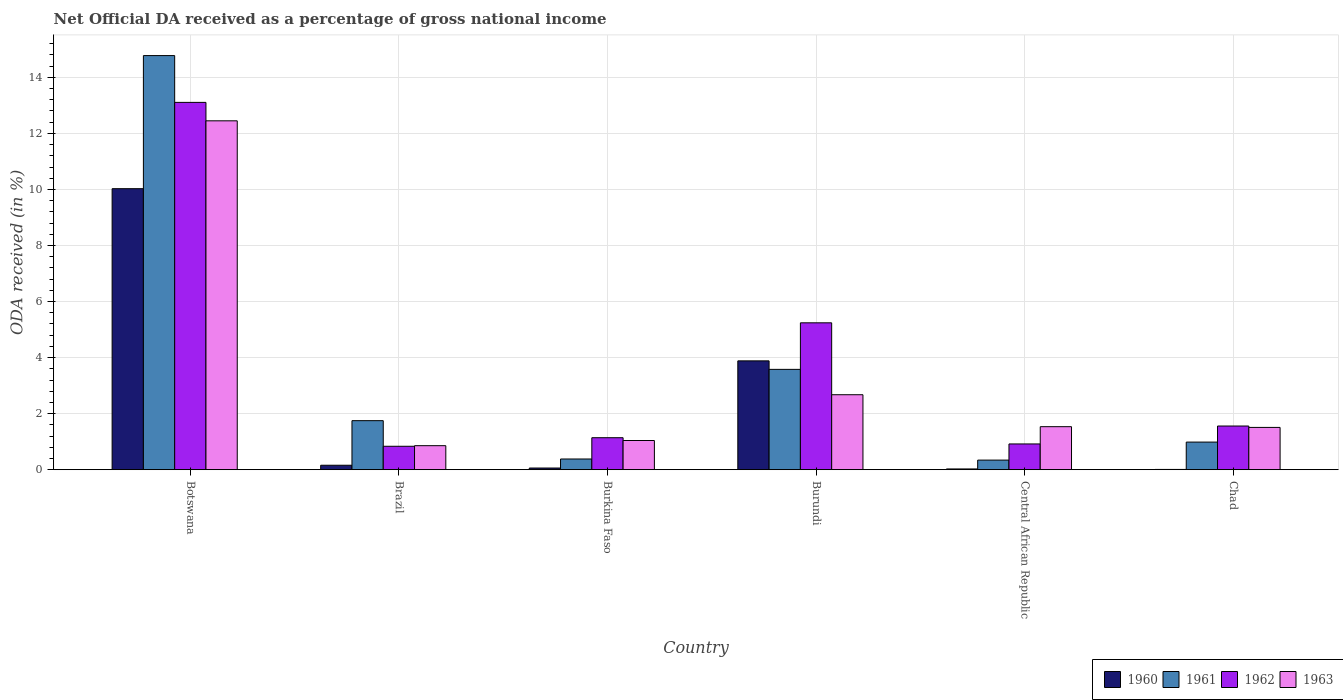How many different coloured bars are there?
Offer a terse response. 4. Are the number of bars on each tick of the X-axis equal?
Provide a succinct answer. Yes. How many bars are there on the 1st tick from the left?
Provide a short and direct response. 4. How many bars are there on the 1st tick from the right?
Your response must be concise. 4. What is the label of the 2nd group of bars from the left?
Give a very brief answer. Brazil. In how many cases, is the number of bars for a given country not equal to the number of legend labels?
Your answer should be very brief. 0. What is the net official DA received in 1962 in Burundi?
Offer a terse response. 5.24. Across all countries, what is the maximum net official DA received in 1962?
Make the answer very short. 13.11. Across all countries, what is the minimum net official DA received in 1960?
Your answer should be very brief. 0.01. In which country was the net official DA received in 1961 maximum?
Make the answer very short. Botswana. In which country was the net official DA received in 1961 minimum?
Ensure brevity in your answer.  Central African Republic. What is the total net official DA received in 1960 in the graph?
Your answer should be compact. 14.17. What is the difference between the net official DA received in 1961 in Botswana and that in Burkina Faso?
Your answer should be very brief. 14.4. What is the difference between the net official DA received in 1963 in Brazil and the net official DA received in 1960 in Burundi?
Your response must be concise. -3.03. What is the average net official DA received in 1961 per country?
Keep it short and to the point. 3.64. What is the difference between the net official DA received of/in 1963 and net official DA received of/in 1962 in Central African Republic?
Ensure brevity in your answer.  0.62. In how many countries, is the net official DA received in 1962 greater than 1.2000000000000002 %?
Provide a short and direct response. 3. What is the ratio of the net official DA received in 1960 in Burkina Faso to that in Chad?
Ensure brevity in your answer.  6.2. Is the net official DA received in 1963 in Burundi less than that in Chad?
Your answer should be very brief. No. Is the difference between the net official DA received in 1963 in Burkina Faso and Chad greater than the difference between the net official DA received in 1962 in Burkina Faso and Chad?
Provide a succinct answer. No. What is the difference between the highest and the second highest net official DA received in 1963?
Ensure brevity in your answer.  -1.14. What is the difference between the highest and the lowest net official DA received in 1962?
Your answer should be very brief. 12.27. Is the sum of the net official DA received in 1963 in Brazil and Chad greater than the maximum net official DA received in 1962 across all countries?
Your answer should be very brief. No. Is it the case that in every country, the sum of the net official DA received in 1961 and net official DA received in 1960 is greater than the sum of net official DA received in 1962 and net official DA received in 1963?
Your answer should be very brief. No. Is it the case that in every country, the sum of the net official DA received in 1962 and net official DA received in 1960 is greater than the net official DA received in 1961?
Your answer should be compact. No. Are all the bars in the graph horizontal?
Provide a succinct answer. No. Does the graph contain any zero values?
Offer a very short reply. No. How many legend labels are there?
Ensure brevity in your answer.  4. What is the title of the graph?
Offer a terse response. Net Official DA received as a percentage of gross national income. What is the label or title of the X-axis?
Your answer should be very brief. Country. What is the label or title of the Y-axis?
Your answer should be very brief. ODA received (in %). What is the ODA received (in %) of 1960 in Botswana?
Your answer should be compact. 10.03. What is the ODA received (in %) in 1961 in Botswana?
Offer a terse response. 14.78. What is the ODA received (in %) of 1962 in Botswana?
Offer a terse response. 13.11. What is the ODA received (in %) in 1963 in Botswana?
Provide a short and direct response. 12.45. What is the ODA received (in %) in 1960 in Brazil?
Keep it short and to the point. 0.16. What is the ODA received (in %) of 1961 in Brazil?
Your response must be concise. 1.75. What is the ODA received (in %) in 1962 in Brazil?
Offer a terse response. 0.84. What is the ODA received (in %) in 1963 in Brazil?
Make the answer very short. 0.86. What is the ODA received (in %) of 1960 in Burkina Faso?
Offer a terse response. 0.06. What is the ODA received (in %) of 1961 in Burkina Faso?
Your answer should be very brief. 0.38. What is the ODA received (in %) in 1962 in Burkina Faso?
Offer a terse response. 1.14. What is the ODA received (in %) in 1963 in Burkina Faso?
Offer a very short reply. 1.04. What is the ODA received (in %) of 1960 in Burundi?
Offer a terse response. 3.88. What is the ODA received (in %) of 1961 in Burundi?
Offer a terse response. 3.58. What is the ODA received (in %) in 1962 in Burundi?
Ensure brevity in your answer.  5.24. What is the ODA received (in %) of 1963 in Burundi?
Give a very brief answer. 2.68. What is the ODA received (in %) in 1960 in Central African Republic?
Give a very brief answer. 0.03. What is the ODA received (in %) in 1961 in Central African Republic?
Offer a very short reply. 0.34. What is the ODA received (in %) in 1962 in Central African Republic?
Your answer should be very brief. 0.92. What is the ODA received (in %) in 1963 in Central African Republic?
Offer a terse response. 1.54. What is the ODA received (in %) of 1960 in Chad?
Offer a very short reply. 0.01. What is the ODA received (in %) of 1961 in Chad?
Offer a very short reply. 0.99. What is the ODA received (in %) in 1962 in Chad?
Give a very brief answer. 1.56. What is the ODA received (in %) of 1963 in Chad?
Make the answer very short. 1.51. Across all countries, what is the maximum ODA received (in %) in 1960?
Your answer should be very brief. 10.03. Across all countries, what is the maximum ODA received (in %) of 1961?
Make the answer very short. 14.78. Across all countries, what is the maximum ODA received (in %) of 1962?
Offer a very short reply. 13.11. Across all countries, what is the maximum ODA received (in %) in 1963?
Provide a short and direct response. 12.45. Across all countries, what is the minimum ODA received (in %) in 1960?
Your answer should be very brief. 0.01. Across all countries, what is the minimum ODA received (in %) in 1961?
Your response must be concise. 0.34. Across all countries, what is the minimum ODA received (in %) in 1962?
Ensure brevity in your answer.  0.84. Across all countries, what is the minimum ODA received (in %) of 1963?
Your answer should be compact. 0.86. What is the total ODA received (in %) in 1960 in the graph?
Your answer should be compact. 14.17. What is the total ODA received (in %) of 1961 in the graph?
Provide a short and direct response. 21.82. What is the total ODA received (in %) in 1962 in the graph?
Provide a short and direct response. 22.8. What is the total ODA received (in %) of 1963 in the graph?
Provide a short and direct response. 20.07. What is the difference between the ODA received (in %) in 1960 in Botswana and that in Brazil?
Offer a terse response. 9.87. What is the difference between the ODA received (in %) in 1961 in Botswana and that in Brazil?
Your response must be concise. 13.03. What is the difference between the ODA received (in %) in 1962 in Botswana and that in Brazil?
Offer a terse response. 12.27. What is the difference between the ODA received (in %) of 1963 in Botswana and that in Brazil?
Offer a very short reply. 11.59. What is the difference between the ODA received (in %) of 1960 in Botswana and that in Burkina Faso?
Give a very brief answer. 9.97. What is the difference between the ODA received (in %) of 1961 in Botswana and that in Burkina Faso?
Your response must be concise. 14.39. What is the difference between the ODA received (in %) in 1962 in Botswana and that in Burkina Faso?
Your answer should be very brief. 11.97. What is the difference between the ODA received (in %) in 1963 in Botswana and that in Burkina Faso?
Keep it short and to the point. 11.41. What is the difference between the ODA received (in %) in 1960 in Botswana and that in Burundi?
Your answer should be compact. 6.14. What is the difference between the ODA received (in %) in 1961 in Botswana and that in Burundi?
Your answer should be compact. 11.2. What is the difference between the ODA received (in %) in 1962 in Botswana and that in Burundi?
Provide a short and direct response. 7.87. What is the difference between the ODA received (in %) in 1963 in Botswana and that in Burundi?
Give a very brief answer. 9.77. What is the difference between the ODA received (in %) in 1960 in Botswana and that in Central African Republic?
Provide a short and direct response. 10. What is the difference between the ODA received (in %) of 1961 in Botswana and that in Central African Republic?
Ensure brevity in your answer.  14.43. What is the difference between the ODA received (in %) of 1962 in Botswana and that in Central African Republic?
Your answer should be very brief. 12.19. What is the difference between the ODA received (in %) in 1963 in Botswana and that in Central African Republic?
Keep it short and to the point. 10.91. What is the difference between the ODA received (in %) in 1960 in Botswana and that in Chad?
Your answer should be very brief. 10.02. What is the difference between the ODA received (in %) of 1961 in Botswana and that in Chad?
Give a very brief answer. 13.79. What is the difference between the ODA received (in %) of 1962 in Botswana and that in Chad?
Keep it short and to the point. 11.55. What is the difference between the ODA received (in %) in 1963 in Botswana and that in Chad?
Offer a terse response. 10.94. What is the difference between the ODA received (in %) in 1960 in Brazil and that in Burkina Faso?
Offer a very short reply. 0.1. What is the difference between the ODA received (in %) of 1961 in Brazil and that in Burkina Faso?
Your answer should be very brief. 1.37. What is the difference between the ODA received (in %) in 1962 in Brazil and that in Burkina Faso?
Your answer should be compact. -0.31. What is the difference between the ODA received (in %) of 1963 in Brazil and that in Burkina Faso?
Your answer should be compact. -0.18. What is the difference between the ODA received (in %) in 1960 in Brazil and that in Burundi?
Make the answer very short. -3.72. What is the difference between the ODA received (in %) in 1961 in Brazil and that in Burundi?
Your answer should be compact. -1.83. What is the difference between the ODA received (in %) of 1962 in Brazil and that in Burundi?
Your answer should be compact. -4.41. What is the difference between the ODA received (in %) in 1963 in Brazil and that in Burundi?
Provide a short and direct response. -1.82. What is the difference between the ODA received (in %) of 1960 in Brazil and that in Central African Republic?
Offer a very short reply. 0.13. What is the difference between the ODA received (in %) in 1961 in Brazil and that in Central African Republic?
Your response must be concise. 1.41. What is the difference between the ODA received (in %) of 1962 in Brazil and that in Central African Republic?
Keep it short and to the point. -0.08. What is the difference between the ODA received (in %) of 1963 in Brazil and that in Central African Republic?
Your answer should be compact. -0.68. What is the difference between the ODA received (in %) of 1960 in Brazil and that in Chad?
Your answer should be compact. 0.15. What is the difference between the ODA received (in %) of 1961 in Brazil and that in Chad?
Provide a short and direct response. 0.76. What is the difference between the ODA received (in %) in 1962 in Brazil and that in Chad?
Provide a succinct answer. -0.72. What is the difference between the ODA received (in %) of 1963 in Brazil and that in Chad?
Provide a succinct answer. -0.65. What is the difference between the ODA received (in %) in 1960 in Burkina Faso and that in Burundi?
Offer a very short reply. -3.82. What is the difference between the ODA received (in %) of 1961 in Burkina Faso and that in Burundi?
Make the answer very short. -3.2. What is the difference between the ODA received (in %) of 1962 in Burkina Faso and that in Burundi?
Your answer should be compact. -4.1. What is the difference between the ODA received (in %) in 1963 in Burkina Faso and that in Burundi?
Offer a very short reply. -1.63. What is the difference between the ODA received (in %) of 1960 in Burkina Faso and that in Central African Republic?
Offer a very short reply. 0.03. What is the difference between the ODA received (in %) of 1961 in Burkina Faso and that in Central African Republic?
Make the answer very short. 0.04. What is the difference between the ODA received (in %) of 1962 in Burkina Faso and that in Central African Republic?
Give a very brief answer. 0.22. What is the difference between the ODA received (in %) of 1963 in Burkina Faso and that in Central African Republic?
Your answer should be compact. -0.49. What is the difference between the ODA received (in %) in 1960 in Burkina Faso and that in Chad?
Keep it short and to the point. 0.05. What is the difference between the ODA received (in %) in 1961 in Burkina Faso and that in Chad?
Your answer should be compact. -0.6. What is the difference between the ODA received (in %) of 1962 in Burkina Faso and that in Chad?
Keep it short and to the point. -0.42. What is the difference between the ODA received (in %) in 1963 in Burkina Faso and that in Chad?
Your answer should be compact. -0.47. What is the difference between the ODA received (in %) in 1960 in Burundi and that in Central African Republic?
Provide a short and direct response. 3.86. What is the difference between the ODA received (in %) in 1961 in Burundi and that in Central African Republic?
Provide a short and direct response. 3.24. What is the difference between the ODA received (in %) in 1962 in Burundi and that in Central African Republic?
Keep it short and to the point. 4.32. What is the difference between the ODA received (in %) in 1963 in Burundi and that in Central African Republic?
Your answer should be compact. 1.14. What is the difference between the ODA received (in %) in 1960 in Burundi and that in Chad?
Offer a very short reply. 3.87. What is the difference between the ODA received (in %) of 1961 in Burundi and that in Chad?
Provide a short and direct response. 2.6. What is the difference between the ODA received (in %) in 1962 in Burundi and that in Chad?
Ensure brevity in your answer.  3.68. What is the difference between the ODA received (in %) in 1963 in Burundi and that in Chad?
Make the answer very short. 1.17. What is the difference between the ODA received (in %) in 1960 in Central African Republic and that in Chad?
Your response must be concise. 0.02. What is the difference between the ODA received (in %) in 1961 in Central African Republic and that in Chad?
Provide a short and direct response. -0.64. What is the difference between the ODA received (in %) in 1962 in Central African Republic and that in Chad?
Offer a terse response. -0.64. What is the difference between the ODA received (in %) in 1963 in Central African Republic and that in Chad?
Provide a succinct answer. 0.03. What is the difference between the ODA received (in %) in 1960 in Botswana and the ODA received (in %) in 1961 in Brazil?
Your answer should be very brief. 8.28. What is the difference between the ODA received (in %) in 1960 in Botswana and the ODA received (in %) in 1962 in Brazil?
Offer a terse response. 9.19. What is the difference between the ODA received (in %) of 1960 in Botswana and the ODA received (in %) of 1963 in Brazil?
Ensure brevity in your answer.  9.17. What is the difference between the ODA received (in %) in 1961 in Botswana and the ODA received (in %) in 1962 in Brazil?
Your answer should be compact. 13.94. What is the difference between the ODA received (in %) of 1961 in Botswana and the ODA received (in %) of 1963 in Brazil?
Ensure brevity in your answer.  13.92. What is the difference between the ODA received (in %) of 1962 in Botswana and the ODA received (in %) of 1963 in Brazil?
Give a very brief answer. 12.25. What is the difference between the ODA received (in %) in 1960 in Botswana and the ODA received (in %) in 1961 in Burkina Faso?
Offer a terse response. 9.65. What is the difference between the ODA received (in %) in 1960 in Botswana and the ODA received (in %) in 1962 in Burkina Faso?
Your response must be concise. 8.89. What is the difference between the ODA received (in %) of 1960 in Botswana and the ODA received (in %) of 1963 in Burkina Faso?
Offer a very short reply. 8.99. What is the difference between the ODA received (in %) of 1961 in Botswana and the ODA received (in %) of 1962 in Burkina Faso?
Your answer should be compact. 13.64. What is the difference between the ODA received (in %) of 1961 in Botswana and the ODA received (in %) of 1963 in Burkina Faso?
Make the answer very short. 13.74. What is the difference between the ODA received (in %) of 1962 in Botswana and the ODA received (in %) of 1963 in Burkina Faso?
Your response must be concise. 12.07. What is the difference between the ODA received (in %) in 1960 in Botswana and the ODA received (in %) in 1961 in Burundi?
Your response must be concise. 6.45. What is the difference between the ODA received (in %) of 1960 in Botswana and the ODA received (in %) of 1962 in Burundi?
Ensure brevity in your answer.  4.79. What is the difference between the ODA received (in %) of 1960 in Botswana and the ODA received (in %) of 1963 in Burundi?
Keep it short and to the point. 7.35. What is the difference between the ODA received (in %) in 1961 in Botswana and the ODA received (in %) in 1962 in Burundi?
Give a very brief answer. 9.54. What is the difference between the ODA received (in %) in 1961 in Botswana and the ODA received (in %) in 1963 in Burundi?
Provide a succinct answer. 12.1. What is the difference between the ODA received (in %) of 1962 in Botswana and the ODA received (in %) of 1963 in Burundi?
Offer a very short reply. 10.43. What is the difference between the ODA received (in %) of 1960 in Botswana and the ODA received (in %) of 1961 in Central African Republic?
Make the answer very short. 9.69. What is the difference between the ODA received (in %) of 1960 in Botswana and the ODA received (in %) of 1962 in Central African Republic?
Ensure brevity in your answer.  9.11. What is the difference between the ODA received (in %) in 1960 in Botswana and the ODA received (in %) in 1963 in Central African Republic?
Offer a terse response. 8.49. What is the difference between the ODA received (in %) in 1961 in Botswana and the ODA received (in %) in 1962 in Central African Republic?
Offer a terse response. 13.86. What is the difference between the ODA received (in %) in 1961 in Botswana and the ODA received (in %) in 1963 in Central African Republic?
Offer a terse response. 13.24. What is the difference between the ODA received (in %) of 1962 in Botswana and the ODA received (in %) of 1963 in Central African Republic?
Give a very brief answer. 11.57. What is the difference between the ODA received (in %) in 1960 in Botswana and the ODA received (in %) in 1961 in Chad?
Ensure brevity in your answer.  9.04. What is the difference between the ODA received (in %) in 1960 in Botswana and the ODA received (in %) in 1962 in Chad?
Offer a terse response. 8.47. What is the difference between the ODA received (in %) of 1960 in Botswana and the ODA received (in %) of 1963 in Chad?
Your answer should be very brief. 8.52. What is the difference between the ODA received (in %) of 1961 in Botswana and the ODA received (in %) of 1962 in Chad?
Your response must be concise. 13.22. What is the difference between the ODA received (in %) in 1961 in Botswana and the ODA received (in %) in 1963 in Chad?
Provide a succinct answer. 13.27. What is the difference between the ODA received (in %) in 1962 in Botswana and the ODA received (in %) in 1963 in Chad?
Your response must be concise. 11.6. What is the difference between the ODA received (in %) in 1960 in Brazil and the ODA received (in %) in 1961 in Burkina Faso?
Ensure brevity in your answer.  -0.22. What is the difference between the ODA received (in %) of 1960 in Brazil and the ODA received (in %) of 1962 in Burkina Faso?
Offer a very short reply. -0.98. What is the difference between the ODA received (in %) in 1960 in Brazil and the ODA received (in %) in 1963 in Burkina Faso?
Offer a very short reply. -0.88. What is the difference between the ODA received (in %) of 1961 in Brazil and the ODA received (in %) of 1962 in Burkina Faso?
Ensure brevity in your answer.  0.61. What is the difference between the ODA received (in %) of 1961 in Brazil and the ODA received (in %) of 1963 in Burkina Faso?
Provide a short and direct response. 0.71. What is the difference between the ODA received (in %) of 1962 in Brazil and the ODA received (in %) of 1963 in Burkina Faso?
Provide a short and direct response. -0.21. What is the difference between the ODA received (in %) of 1960 in Brazil and the ODA received (in %) of 1961 in Burundi?
Provide a succinct answer. -3.42. What is the difference between the ODA received (in %) of 1960 in Brazil and the ODA received (in %) of 1962 in Burundi?
Offer a very short reply. -5.08. What is the difference between the ODA received (in %) in 1960 in Brazil and the ODA received (in %) in 1963 in Burundi?
Your response must be concise. -2.52. What is the difference between the ODA received (in %) of 1961 in Brazil and the ODA received (in %) of 1962 in Burundi?
Offer a terse response. -3.49. What is the difference between the ODA received (in %) in 1961 in Brazil and the ODA received (in %) in 1963 in Burundi?
Your answer should be compact. -0.93. What is the difference between the ODA received (in %) of 1962 in Brazil and the ODA received (in %) of 1963 in Burundi?
Your answer should be compact. -1.84. What is the difference between the ODA received (in %) of 1960 in Brazil and the ODA received (in %) of 1961 in Central African Republic?
Ensure brevity in your answer.  -0.18. What is the difference between the ODA received (in %) of 1960 in Brazil and the ODA received (in %) of 1962 in Central African Republic?
Your answer should be compact. -0.76. What is the difference between the ODA received (in %) of 1960 in Brazil and the ODA received (in %) of 1963 in Central African Republic?
Ensure brevity in your answer.  -1.38. What is the difference between the ODA received (in %) in 1961 in Brazil and the ODA received (in %) in 1962 in Central African Republic?
Offer a very short reply. 0.83. What is the difference between the ODA received (in %) of 1961 in Brazil and the ODA received (in %) of 1963 in Central African Republic?
Your answer should be compact. 0.21. What is the difference between the ODA received (in %) in 1962 in Brazil and the ODA received (in %) in 1963 in Central African Republic?
Give a very brief answer. -0.7. What is the difference between the ODA received (in %) of 1960 in Brazil and the ODA received (in %) of 1961 in Chad?
Provide a succinct answer. -0.83. What is the difference between the ODA received (in %) of 1960 in Brazil and the ODA received (in %) of 1962 in Chad?
Make the answer very short. -1.4. What is the difference between the ODA received (in %) in 1960 in Brazil and the ODA received (in %) in 1963 in Chad?
Offer a very short reply. -1.35. What is the difference between the ODA received (in %) in 1961 in Brazil and the ODA received (in %) in 1962 in Chad?
Give a very brief answer. 0.19. What is the difference between the ODA received (in %) of 1961 in Brazil and the ODA received (in %) of 1963 in Chad?
Your answer should be compact. 0.24. What is the difference between the ODA received (in %) in 1962 in Brazil and the ODA received (in %) in 1963 in Chad?
Offer a terse response. -0.67. What is the difference between the ODA received (in %) in 1960 in Burkina Faso and the ODA received (in %) in 1961 in Burundi?
Provide a succinct answer. -3.52. What is the difference between the ODA received (in %) in 1960 in Burkina Faso and the ODA received (in %) in 1962 in Burundi?
Give a very brief answer. -5.18. What is the difference between the ODA received (in %) of 1960 in Burkina Faso and the ODA received (in %) of 1963 in Burundi?
Offer a very short reply. -2.62. What is the difference between the ODA received (in %) in 1961 in Burkina Faso and the ODA received (in %) in 1962 in Burundi?
Make the answer very short. -4.86. What is the difference between the ODA received (in %) of 1961 in Burkina Faso and the ODA received (in %) of 1963 in Burundi?
Keep it short and to the point. -2.29. What is the difference between the ODA received (in %) in 1962 in Burkina Faso and the ODA received (in %) in 1963 in Burundi?
Offer a very short reply. -1.53. What is the difference between the ODA received (in %) in 1960 in Burkina Faso and the ODA received (in %) in 1961 in Central African Republic?
Your response must be concise. -0.28. What is the difference between the ODA received (in %) in 1960 in Burkina Faso and the ODA received (in %) in 1962 in Central African Republic?
Your answer should be very brief. -0.86. What is the difference between the ODA received (in %) in 1960 in Burkina Faso and the ODA received (in %) in 1963 in Central African Republic?
Provide a succinct answer. -1.48. What is the difference between the ODA received (in %) of 1961 in Burkina Faso and the ODA received (in %) of 1962 in Central African Republic?
Offer a terse response. -0.54. What is the difference between the ODA received (in %) in 1961 in Burkina Faso and the ODA received (in %) in 1963 in Central African Republic?
Give a very brief answer. -1.15. What is the difference between the ODA received (in %) of 1962 in Burkina Faso and the ODA received (in %) of 1963 in Central African Republic?
Your response must be concise. -0.39. What is the difference between the ODA received (in %) of 1960 in Burkina Faso and the ODA received (in %) of 1961 in Chad?
Give a very brief answer. -0.93. What is the difference between the ODA received (in %) of 1960 in Burkina Faso and the ODA received (in %) of 1962 in Chad?
Provide a short and direct response. -1.5. What is the difference between the ODA received (in %) in 1960 in Burkina Faso and the ODA received (in %) in 1963 in Chad?
Provide a short and direct response. -1.45. What is the difference between the ODA received (in %) of 1961 in Burkina Faso and the ODA received (in %) of 1962 in Chad?
Offer a terse response. -1.18. What is the difference between the ODA received (in %) in 1961 in Burkina Faso and the ODA received (in %) in 1963 in Chad?
Provide a short and direct response. -1.13. What is the difference between the ODA received (in %) in 1962 in Burkina Faso and the ODA received (in %) in 1963 in Chad?
Make the answer very short. -0.37. What is the difference between the ODA received (in %) in 1960 in Burundi and the ODA received (in %) in 1961 in Central African Republic?
Provide a succinct answer. 3.54. What is the difference between the ODA received (in %) of 1960 in Burundi and the ODA received (in %) of 1962 in Central African Republic?
Offer a terse response. 2.96. What is the difference between the ODA received (in %) of 1960 in Burundi and the ODA received (in %) of 1963 in Central African Republic?
Offer a very short reply. 2.35. What is the difference between the ODA received (in %) in 1961 in Burundi and the ODA received (in %) in 1962 in Central African Republic?
Your answer should be very brief. 2.66. What is the difference between the ODA received (in %) of 1961 in Burundi and the ODA received (in %) of 1963 in Central African Republic?
Make the answer very short. 2.05. What is the difference between the ODA received (in %) in 1962 in Burundi and the ODA received (in %) in 1963 in Central African Republic?
Keep it short and to the point. 3.71. What is the difference between the ODA received (in %) of 1960 in Burundi and the ODA received (in %) of 1961 in Chad?
Make the answer very short. 2.9. What is the difference between the ODA received (in %) in 1960 in Burundi and the ODA received (in %) in 1962 in Chad?
Your answer should be compact. 2.33. What is the difference between the ODA received (in %) in 1960 in Burundi and the ODA received (in %) in 1963 in Chad?
Your answer should be compact. 2.37. What is the difference between the ODA received (in %) in 1961 in Burundi and the ODA received (in %) in 1962 in Chad?
Your response must be concise. 2.02. What is the difference between the ODA received (in %) in 1961 in Burundi and the ODA received (in %) in 1963 in Chad?
Provide a succinct answer. 2.07. What is the difference between the ODA received (in %) of 1962 in Burundi and the ODA received (in %) of 1963 in Chad?
Provide a short and direct response. 3.73. What is the difference between the ODA received (in %) of 1960 in Central African Republic and the ODA received (in %) of 1961 in Chad?
Your response must be concise. -0.96. What is the difference between the ODA received (in %) in 1960 in Central African Republic and the ODA received (in %) in 1962 in Chad?
Give a very brief answer. -1.53. What is the difference between the ODA received (in %) of 1960 in Central African Republic and the ODA received (in %) of 1963 in Chad?
Your answer should be very brief. -1.48. What is the difference between the ODA received (in %) of 1961 in Central African Republic and the ODA received (in %) of 1962 in Chad?
Provide a short and direct response. -1.22. What is the difference between the ODA received (in %) of 1961 in Central African Republic and the ODA received (in %) of 1963 in Chad?
Give a very brief answer. -1.17. What is the difference between the ODA received (in %) in 1962 in Central African Republic and the ODA received (in %) in 1963 in Chad?
Your answer should be very brief. -0.59. What is the average ODA received (in %) of 1960 per country?
Offer a terse response. 2.36. What is the average ODA received (in %) of 1961 per country?
Offer a terse response. 3.64. What is the average ODA received (in %) in 1962 per country?
Provide a short and direct response. 3.8. What is the average ODA received (in %) in 1963 per country?
Make the answer very short. 3.34. What is the difference between the ODA received (in %) of 1960 and ODA received (in %) of 1961 in Botswana?
Offer a terse response. -4.75. What is the difference between the ODA received (in %) of 1960 and ODA received (in %) of 1962 in Botswana?
Your answer should be very brief. -3.08. What is the difference between the ODA received (in %) of 1960 and ODA received (in %) of 1963 in Botswana?
Ensure brevity in your answer.  -2.42. What is the difference between the ODA received (in %) of 1961 and ODA received (in %) of 1962 in Botswana?
Provide a short and direct response. 1.67. What is the difference between the ODA received (in %) of 1961 and ODA received (in %) of 1963 in Botswana?
Give a very brief answer. 2.33. What is the difference between the ODA received (in %) in 1962 and ODA received (in %) in 1963 in Botswana?
Keep it short and to the point. 0.66. What is the difference between the ODA received (in %) in 1960 and ODA received (in %) in 1961 in Brazil?
Provide a short and direct response. -1.59. What is the difference between the ODA received (in %) in 1960 and ODA received (in %) in 1962 in Brazil?
Your response must be concise. -0.68. What is the difference between the ODA received (in %) of 1960 and ODA received (in %) of 1963 in Brazil?
Provide a succinct answer. -0.7. What is the difference between the ODA received (in %) in 1961 and ODA received (in %) in 1962 in Brazil?
Keep it short and to the point. 0.91. What is the difference between the ODA received (in %) of 1961 and ODA received (in %) of 1963 in Brazil?
Give a very brief answer. 0.89. What is the difference between the ODA received (in %) in 1962 and ODA received (in %) in 1963 in Brazil?
Provide a succinct answer. -0.02. What is the difference between the ODA received (in %) of 1960 and ODA received (in %) of 1961 in Burkina Faso?
Keep it short and to the point. -0.32. What is the difference between the ODA received (in %) in 1960 and ODA received (in %) in 1962 in Burkina Faso?
Your answer should be compact. -1.08. What is the difference between the ODA received (in %) in 1960 and ODA received (in %) in 1963 in Burkina Faso?
Give a very brief answer. -0.98. What is the difference between the ODA received (in %) in 1961 and ODA received (in %) in 1962 in Burkina Faso?
Your response must be concise. -0.76. What is the difference between the ODA received (in %) in 1961 and ODA received (in %) in 1963 in Burkina Faso?
Give a very brief answer. -0.66. What is the difference between the ODA received (in %) of 1962 and ODA received (in %) of 1963 in Burkina Faso?
Your answer should be compact. 0.1. What is the difference between the ODA received (in %) in 1960 and ODA received (in %) in 1961 in Burundi?
Make the answer very short. 0.3. What is the difference between the ODA received (in %) of 1960 and ODA received (in %) of 1962 in Burundi?
Offer a terse response. -1.36. What is the difference between the ODA received (in %) of 1960 and ODA received (in %) of 1963 in Burundi?
Give a very brief answer. 1.21. What is the difference between the ODA received (in %) of 1961 and ODA received (in %) of 1962 in Burundi?
Offer a very short reply. -1.66. What is the difference between the ODA received (in %) of 1961 and ODA received (in %) of 1963 in Burundi?
Your answer should be very brief. 0.91. What is the difference between the ODA received (in %) of 1962 and ODA received (in %) of 1963 in Burundi?
Ensure brevity in your answer.  2.57. What is the difference between the ODA received (in %) in 1960 and ODA received (in %) in 1961 in Central African Republic?
Your answer should be compact. -0.32. What is the difference between the ODA received (in %) of 1960 and ODA received (in %) of 1962 in Central African Republic?
Your answer should be very brief. -0.89. What is the difference between the ODA received (in %) of 1960 and ODA received (in %) of 1963 in Central African Republic?
Give a very brief answer. -1.51. What is the difference between the ODA received (in %) in 1961 and ODA received (in %) in 1962 in Central African Republic?
Your answer should be very brief. -0.58. What is the difference between the ODA received (in %) in 1961 and ODA received (in %) in 1963 in Central African Republic?
Offer a very short reply. -1.19. What is the difference between the ODA received (in %) of 1962 and ODA received (in %) of 1963 in Central African Republic?
Give a very brief answer. -0.62. What is the difference between the ODA received (in %) in 1960 and ODA received (in %) in 1961 in Chad?
Your answer should be compact. -0.98. What is the difference between the ODA received (in %) of 1960 and ODA received (in %) of 1962 in Chad?
Ensure brevity in your answer.  -1.55. What is the difference between the ODA received (in %) of 1960 and ODA received (in %) of 1963 in Chad?
Your answer should be very brief. -1.5. What is the difference between the ODA received (in %) in 1961 and ODA received (in %) in 1962 in Chad?
Offer a very short reply. -0.57. What is the difference between the ODA received (in %) in 1961 and ODA received (in %) in 1963 in Chad?
Your answer should be compact. -0.52. What is the difference between the ODA received (in %) of 1962 and ODA received (in %) of 1963 in Chad?
Keep it short and to the point. 0.05. What is the ratio of the ODA received (in %) in 1960 in Botswana to that in Brazil?
Your answer should be compact. 63.08. What is the ratio of the ODA received (in %) in 1961 in Botswana to that in Brazil?
Offer a very short reply. 8.45. What is the ratio of the ODA received (in %) of 1962 in Botswana to that in Brazil?
Provide a short and direct response. 15.68. What is the ratio of the ODA received (in %) in 1963 in Botswana to that in Brazil?
Your answer should be very brief. 14.53. What is the ratio of the ODA received (in %) in 1960 in Botswana to that in Burkina Faso?
Your response must be concise. 167.91. What is the ratio of the ODA received (in %) in 1961 in Botswana to that in Burkina Faso?
Keep it short and to the point. 38.69. What is the ratio of the ODA received (in %) in 1962 in Botswana to that in Burkina Faso?
Give a very brief answer. 11.48. What is the ratio of the ODA received (in %) in 1963 in Botswana to that in Burkina Faso?
Keep it short and to the point. 11.95. What is the ratio of the ODA received (in %) of 1960 in Botswana to that in Burundi?
Your answer should be compact. 2.58. What is the ratio of the ODA received (in %) in 1961 in Botswana to that in Burundi?
Keep it short and to the point. 4.13. What is the ratio of the ODA received (in %) in 1962 in Botswana to that in Burundi?
Make the answer very short. 2.5. What is the ratio of the ODA received (in %) of 1963 in Botswana to that in Burundi?
Offer a terse response. 4.65. What is the ratio of the ODA received (in %) of 1960 in Botswana to that in Central African Republic?
Make the answer very short. 373.52. What is the ratio of the ODA received (in %) in 1961 in Botswana to that in Central African Republic?
Your answer should be very brief. 43.18. What is the ratio of the ODA received (in %) in 1962 in Botswana to that in Central African Republic?
Provide a short and direct response. 14.27. What is the ratio of the ODA received (in %) in 1963 in Botswana to that in Central African Republic?
Your response must be concise. 8.11. What is the ratio of the ODA received (in %) in 1960 in Botswana to that in Chad?
Provide a short and direct response. 1041.08. What is the ratio of the ODA received (in %) in 1961 in Botswana to that in Chad?
Your answer should be compact. 15. What is the ratio of the ODA received (in %) of 1962 in Botswana to that in Chad?
Provide a succinct answer. 8.41. What is the ratio of the ODA received (in %) in 1963 in Botswana to that in Chad?
Your answer should be compact. 8.25. What is the ratio of the ODA received (in %) of 1960 in Brazil to that in Burkina Faso?
Ensure brevity in your answer.  2.66. What is the ratio of the ODA received (in %) in 1961 in Brazil to that in Burkina Faso?
Your response must be concise. 4.58. What is the ratio of the ODA received (in %) in 1962 in Brazil to that in Burkina Faso?
Keep it short and to the point. 0.73. What is the ratio of the ODA received (in %) of 1963 in Brazil to that in Burkina Faso?
Your response must be concise. 0.82. What is the ratio of the ODA received (in %) in 1960 in Brazil to that in Burundi?
Your answer should be very brief. 0.04. What is the ratio of the ODA received (in %) in 1961 in Brazil to that in Burundi?
Offer a terse response. 0.49. What is the ratio of the ODA received (in %) of 1962 in Brazil to that in Burundi?
Ensure brevity in your answer.  0.16. What is the ratio of the ODA received (in %) in 1963 in Brazil to that in Burundi?
Your answer should be compact. 0.32. What is the ratio of the ODA received (in %) of 1960 in Brazil to that in Central African Republic?
Offer a very short reply. 5.92. What is the ratio of the ODA received (in %) in 1961 in Brazil to that in Central African Republic?
Keep it short and to the point. 5.11. What is the ratio of the ODA received (in %) of 1962 in Brazil to that in Central African Republic?
Provide a succinct answer. 0.91. What is the ratio of the ODA received (in %) of 1963 in Brazil to that in Central African Republic?
Provide a succinct answer. 0.56. What is the ratio of the ODA received (in %) of 1960 in Brazil to that in Chad?
Your answer should be very brief. 16.51. What is the ratio of the ODA received (in %) of 1961 in Brazil to that in Chad?
Your answer should be very brief. 1.78. What is the ratio of the ODA received (in %) in 1962 in Brazil to that in Chad?
Give a very brief answer. 0.54. What is the ratio of the ODA received (in %) of 1963 in Brazil to that in Chad?
Give a very brief answer. 0.57. What is the ratio of the ODA received (in %) of 1960 in Burkina Faso to that in Burundi?
Ensure brevity in your answer.  0.02. What is the ratio of the ODA received (in %) in 1961 in Burkina Faso to that in Burundi?
Provide a short and direct response. 0.11. What is the ratio of the ODA received (in %) in 1962 in Burkina Faso to that in Burundi?
Your answer should be compact. 0.22. What is the ratio of the ODA received (in %) of 1963 in Burkina Faso to that in Burundi?
Make the answer very short. 0.39. What is the ratio of the ODA received (in %) of 1960 in Burkina Faso to that in Central African Republic?
Provide a short and direct response. 2.22. What is the ratio of the ODA received (in %) in 1961 in Burkina Faso to that in Central African Republic?
Offer a terse response. 1.12. What is the ratio of the ODA received (in %) of 1962 in Burkina Faso to that in Central African Republic?
Provide a succinct answer. 1.24. What is the ratio of the ODA received (in %) in 1963 in Burkina Faso to that in Central African Republic?
Your response must be concise. 0.68. What is the ratio of the ODA received (in %) of 1960 in Burkina Faso to that in Chad?
Ensure brevity in your answer.  6.2. What is the ratio of the ODA received (in %) of 1961 in Burkina Faso to that in Chad?
Your response must be concise. 0.39. What is the ratio of the ODA received (in %) of 1962 in Burkina Faso to that in Chad?
Give a very brief answer. 0.73. What is the ratio of the ODA received (in %) in 1963 in Burkina Faso to that in Chad?
Your answer should be compact. 0.69. What is the ratio of the ODA received (in %) of 1960 in Burundi to that in Central African Republic?
Your answer should be compact. 144.66. What is the ratio of the ODA received (in %) of 1961 in Burundi to that in Central African Republic?
Ensure brevity in your answer.  10.46. What is the ratio of the ODA received (in %) in 1962 in Burundi to that in Central African Republic?
Your response must be concise. 5.7. What is the ratio of the ODA received (in %) of 1963 in Burundi to that in Central African Republic?
Provide a succinct answer. 1.74. What is the ratio of the ODA received (in %) in 1960 in Burundi to that in Chad?
Offer a terse response. 403.2. What is the ratio of the ODA received (in %) of 1961 in Burundi to that in Chad?
Provide a succinct answer. 3.63. What is the ratio of the ODA received (in %) in 1962 in Burundi to that in Chad?
Ensure brevity in your answer.  3.36. What is the ratio of the ODA received (in %) of 1963 in Burundi to that in Chad?
Your answer should be compact. 1.77. What is the ratio of the ODA received (in %) of 1960 in Central African Republic to that in Chad?
Give a very brief answer. 2.79. What is the ratio of the ODA received (in %) in 1961 in Central African Republic to that in Chad?
Make the answer very short. 0.35. What is the ratio of the ODA received (in %) in 1962 in Central African Republic to that in Chad?
Your response must be concise. 0.59. What is the ratio of the ODA received (in %) in 1963 in Central African Republic to that in Chad?
Offer a terse response. 1.02. What is the difference between the highest and the second highest ODA received (in %) in 1960?
Offer a very short reply. 6.14. What is the difference between the highest and the second highest ODA received (in %) of 1961?
Provide a short and direct response. 11.2. What is the difference between the highest and the second highest ODA received (in %) of 1962?
Offer a very short reply. 7.87. What is the difference between the highest and the second highest ODA received (in %) in 1963?
Make the answer very short. 9.77. What is the difference between the highest and the lowest ODA received (in %) of 1960?
Keep it short and to the point. 10.02. What is the difference between the highest and the lowest ODA received (in %) of 1961?
Offer a terse response. 14.43. What is the difference between the highest and the lowest ODA received (in %) in 1962?
Offer a very short reply. 12.27. What is the difference between the highest and the lowest ODA received (in %) in 1963?
Offer a very short reply. 11.59. 